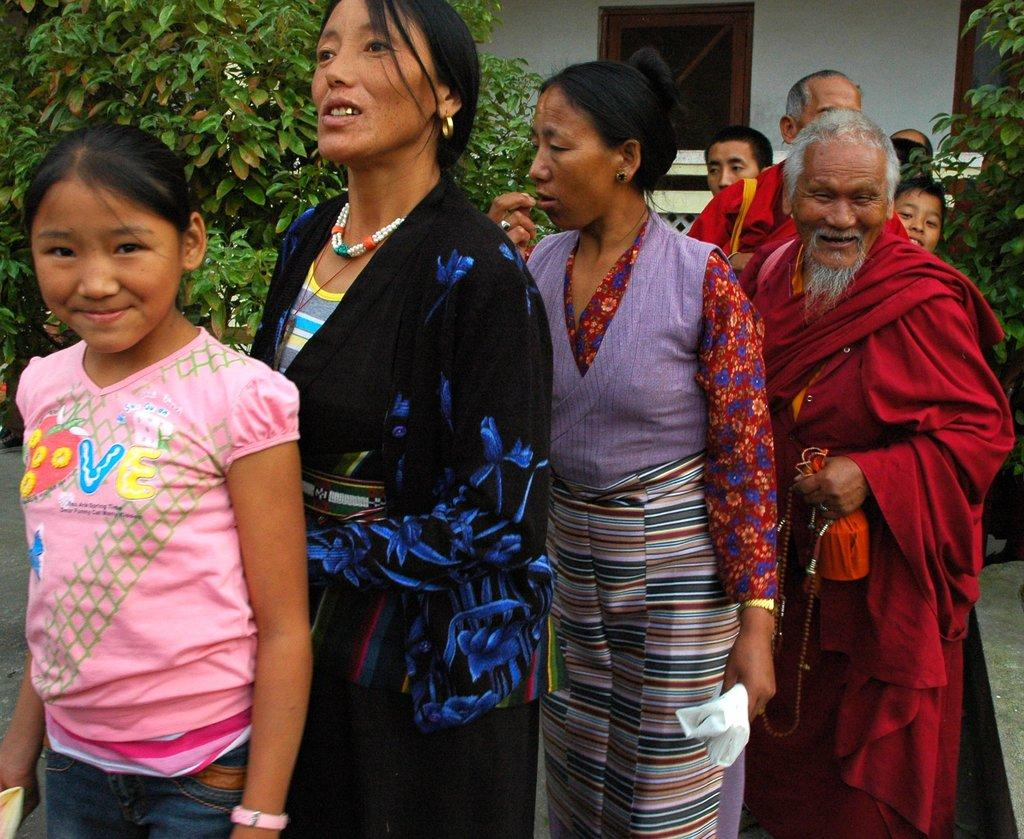What is happening in the image? There are people standing in the image. What can be seen in the background of the image? There is a building and trees in the background of the image. What type of sheet is being used by the actor in the image? There is no actor or sheet present in the image; it features people standing in front of a building and trees. 